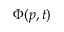<formula> <loc_0><loc_0><loc_500><loc_500>\Phi ( p , t )</formula> 